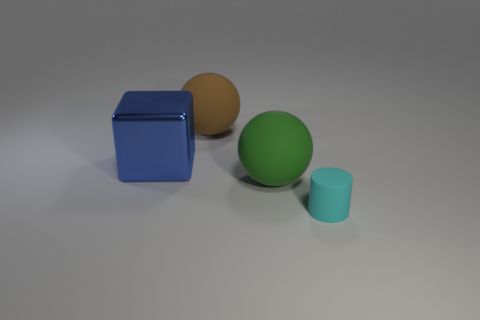Can you describe the lighting and shadows in the scene? The lighting in the scene comes from the upper right, creating soft shadows to the left and below each object, indicating a single light source. 